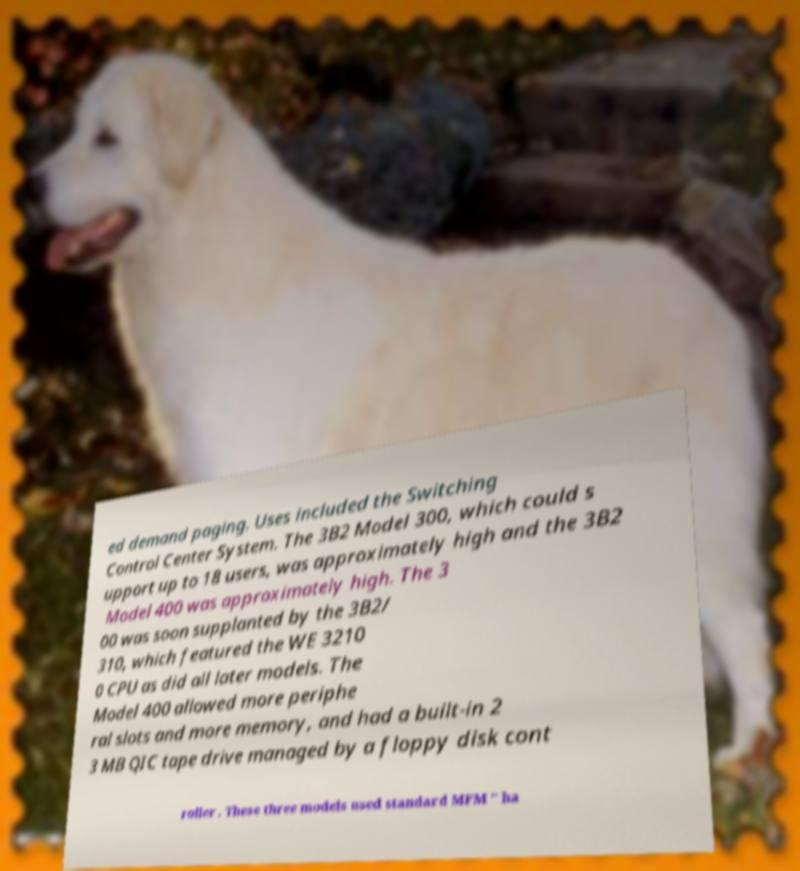Can you read and provide the text displayed in the image?This photo seems to have some interesting text. Can you extract and type it out for me? ed demand paging. Uses included the Switching Control Center System. The 3B2 Model 300, which could s upport up to 18 users, was approximately high and the 3B2 Model 400 was approximately high. The 3 00 was soon supplanted by the 3B2/ 310, which featured the WE 3210 0 CPU as did all later models. The Model 400 allowed more periphe ral slots and more memory, and had a built-in 2 3 MB QIC tape drive managed by a floppy disk cont roller . These three models used standard MFM " ha 